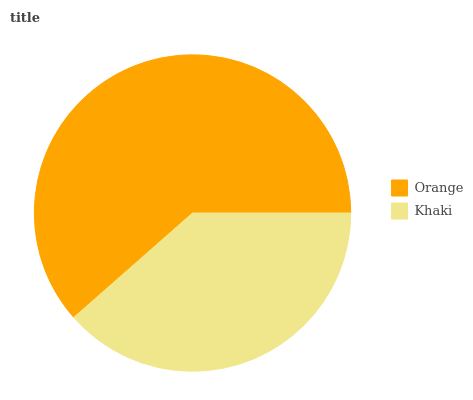Is Khaki the minimum?
Answer yes or no. Yes. Is Orange the maximum?
Answer yes or no. Yes. Is Khaki the maximum?
Answer yes or no. No. Is Orange greater than Khaki?
Answer yes or no. Yes. Is Khaki less than Orange?
Answer yes or no. Yes. Is Khaki greater than Orange?
Answer yes or no. No. Is Orange less than Khaki?
Answer yes or no. No. Is Orange the high median?
Answer yes or no. Yes. Is Khaki the low median?
Answer yes or no. Yes. Is Khaki the high median?
Answer yes or no. No. Is Orange the low median?
Answer yes or no. No. 